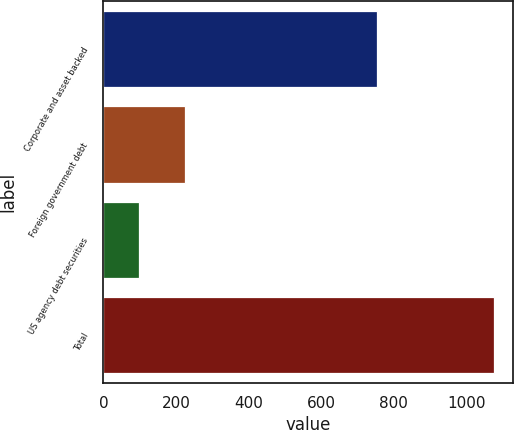Convert chart. <chart><loc_0><loc_0><loc_500><loc_500><bar_chart><fcel>Corporate and asset backed<fcel>Foreign government debt<fcel>US agency debt securities<fcel>Total<nl><fcel>752.9<fcel>224<fcel>99.1<fcel>1076<nl></chart> 